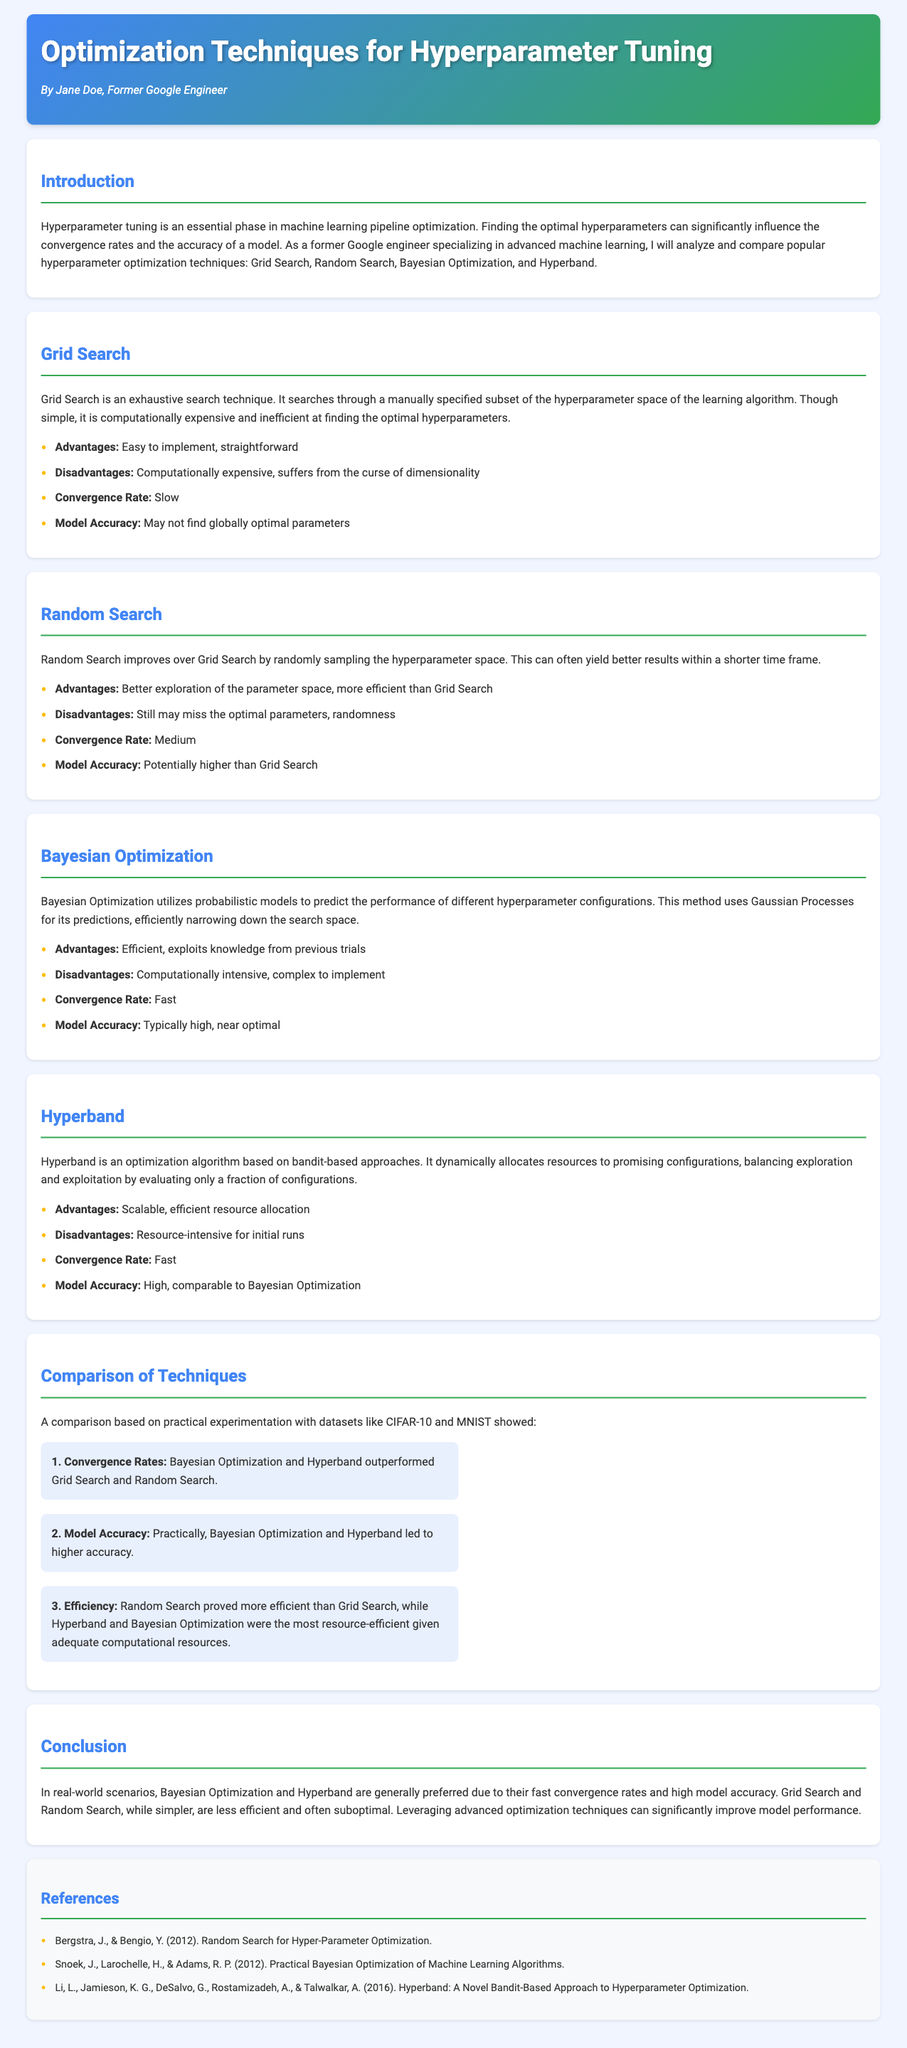what is the title of the document? The title is mentioned in the header of the document.
Answer: Optimization Techniques for Hyperparameter Tuning who is the author of the report? The author is listed right under the title in the header section.
Answer: Jane Doe what are the four hyperparameter optimization techniques discussed? The techniques are listed in the introduction section.
Answer: Grid Search, Random Search, Bayesian Optimization, Hyperband which technique has a slow convergence rate? The convergence rates are mentioned in the respective technique sections.
Answer: Grid Search what is the primary advantage of Bayesian Optimization? The advantages are summarized in the specific section for Bayesian Optimization.
Answer: Efficient, exploits knowledge from previous trials how does Hyperband compare to Random Search in terms of efficiency? The comparison of techniques states their efficiency relative to each other.
Answer: Hyperband and Bayesian Optimization were the most resource-efficient which dataset was mentioned in the comparison of techniques? The datasets used for comparison are explicitly mentioned in the comparison section.
Answer: CIFAR-10 and MNIST what conclusion is drawn about Grid Search and Random Search? The conclusion section refers to these techniques and summarizes their performance.
Answer: Less efficient and often suboptimal what type of programming model does Bayesian Optimization use? The specific section of Bayesian Optimization describes the method used.
Answer: Gaussian Processes 